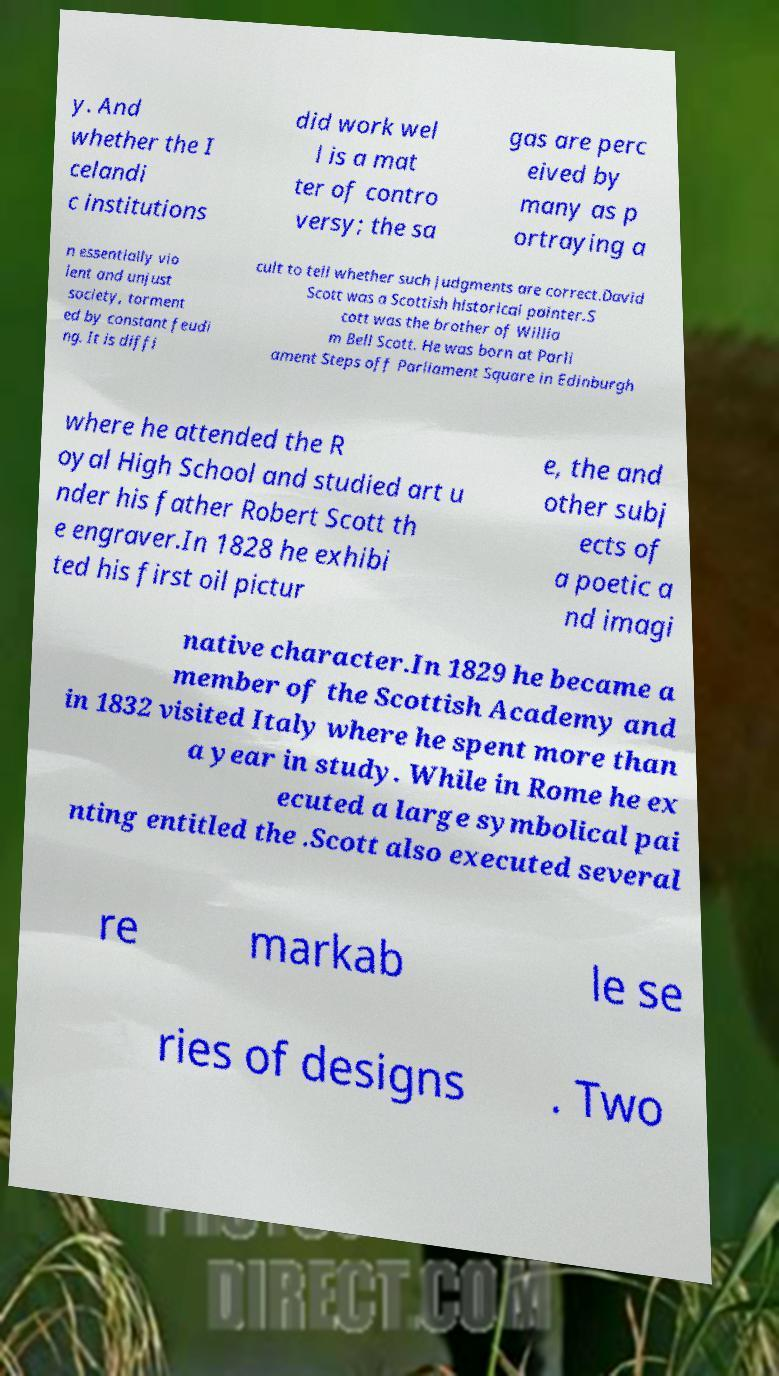Can you accurately transcribe the text from the provided image for me? y. And whether the I celandi c institutions did work wel l is a mat ter of contro versy; the sa gas are perc eived by many as p ortraying a n essentially vio lent and unjust society, torment ed by constant feudi ng. It is diffi cult to tell whether such judgments are correct.David Scott was a Scottish historical painter.S cott was the brother of Willia m Bell Scott. He was born at Parli ament Steps off Parliament Square in Edinburgh where he attended the R oyal High School and studied art u nder his father Robert Scott th e engraver.In 1828 he exhibi ted his first oil pictur e, the and other subj ects of a poetic a nd imagi native character.In 1829 he became a member of the Scottish Academy and in 1832 visited Italy where he spent more than a year in study. While in Rome he ex ecuted a large symbolical pai nting entitled the .Scott also executed several re markab le se ries of designs . Two 